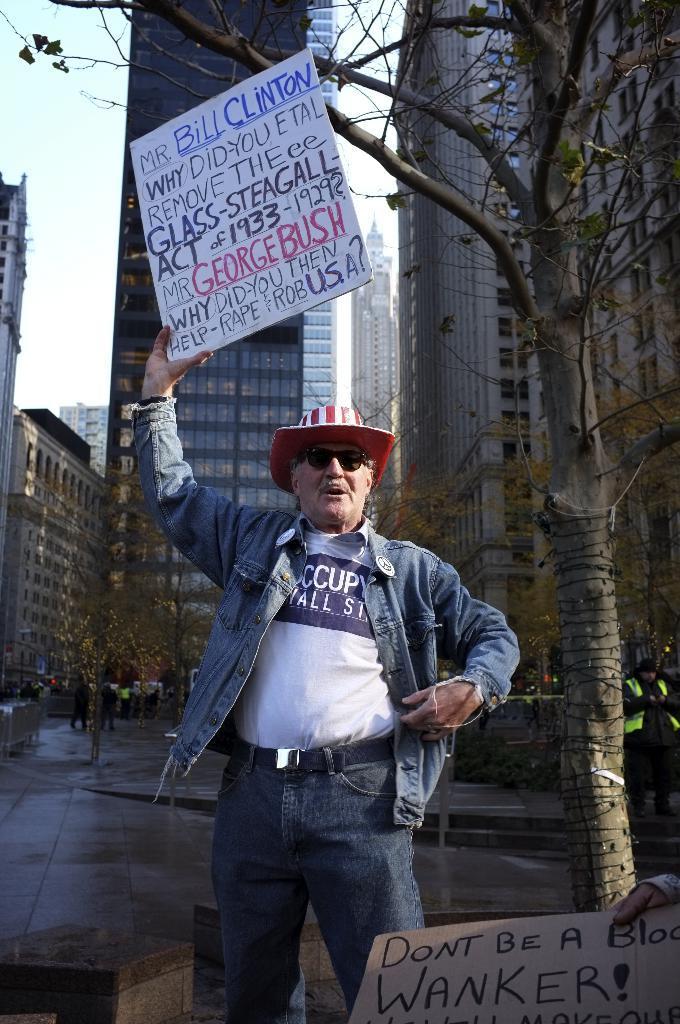Describe this image in one or two sentences. In this image we can see a person and the person is holding a placard with text. Behind the person we can see a group of buildings, persons and trees. At the top we can see the sky. In the bottom right we can see a hand of a person and a placard. 